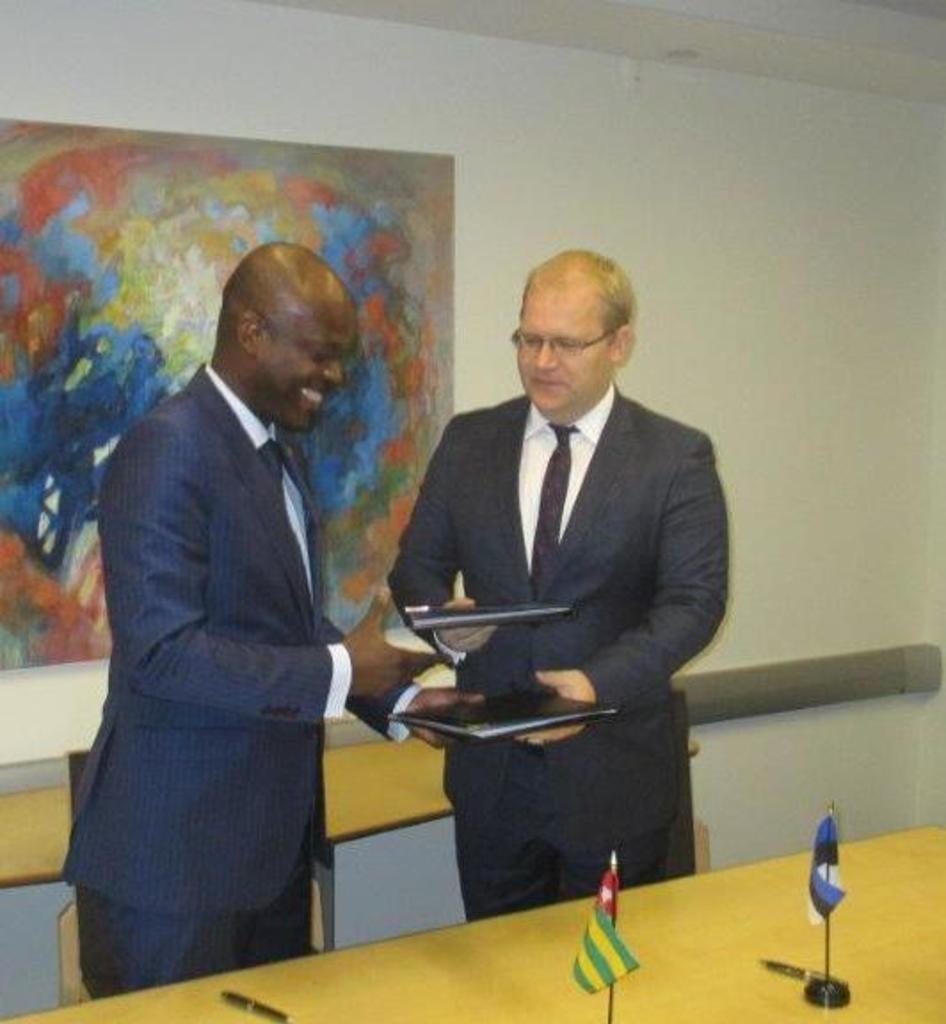Can you describe this image briefly? Here in this picture we can see two men wearing suits and spectacles standing over a place and exchanging some files and we can see both of them are smiling and in front of them we can see a table, on which we can see a couple of pens and flag posts present and behind them we can see chairs present and on the wall we can see a painting present. 